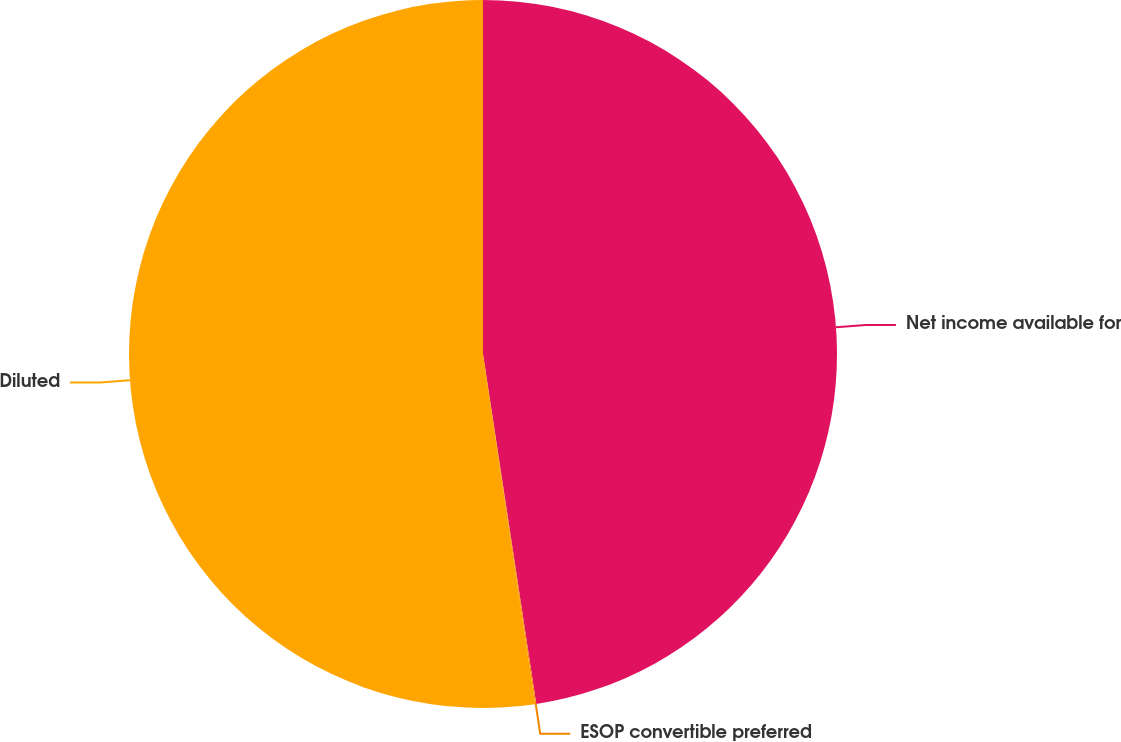Convert chart. <chart><loc_0><loc_0><loc_500><loc_500><pie_chart><fcel>Net income available for<fcel>ESOP convertible preferred<fcel>Diluted<nl><fcel>47.6%<fcel>0.05%<fcel>52.36%<nl></chart> 